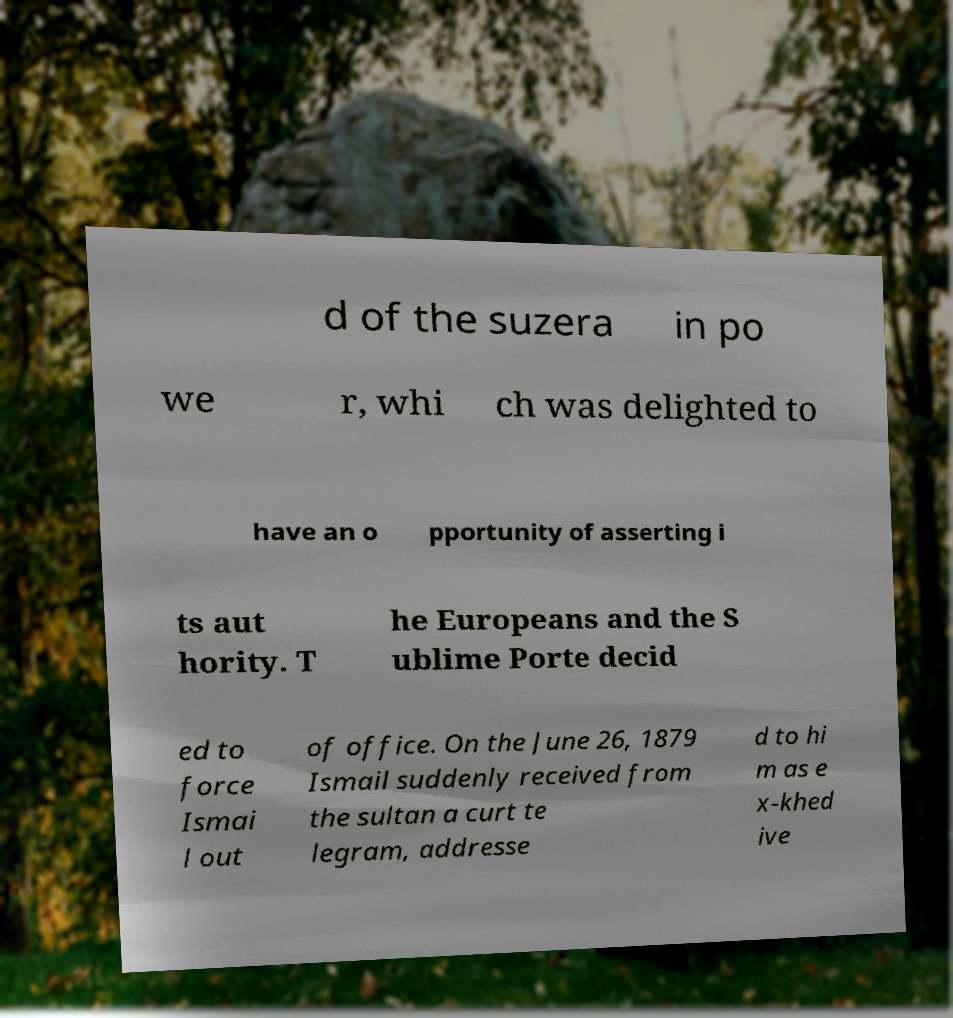Could you extract and type out the text from this image? d of the suzera in po we r, whi ch was delighted to have an o pportunity of asserting i ts aut hority. T he Europeans and the S ublime Porte decid ed to force Ismai l out of office. On the June 26, 1879 Ismail suddenly received from the sultan a curt te legram, addresse d to hi m as e x-khed ive 